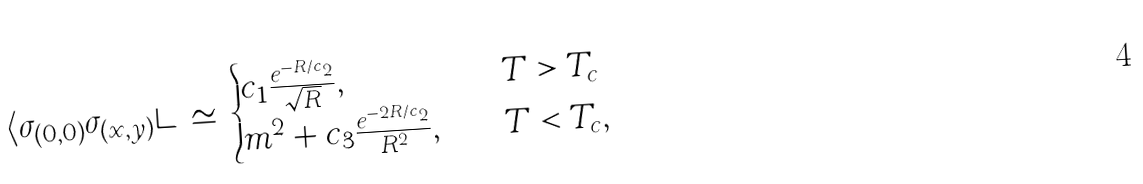Convert formula to latex. <formula><loc_0><loc_0><loc_500><loc_500>\langle \sigma _ { ( 0 , 0 ) } \sigma _ { ( x , y ) } \rangle \, \simeq \, \begin{cases} c _ { 1 } \frac { e ^ { - R / c _ { 2 } } } { \sqrt { R } } , & T > T _ { c } \\ m ^ { 2 } + c _ { 3 } \frac { e ^ { - 2 R / c _ { 2 } } } { R ^ { 2 } } , \quad & T < T _ { c } , \end{cases}</formula> 